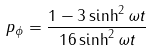Convert formula to latex. <formula><loc_0><loc_0><loc_500><loc_500>p _ { \phi } = \frac { 1 - 3 \sinh ^ { 2 } \omega t } { 1 6 \sinh ^ { 2 } \omega t }</formula> 